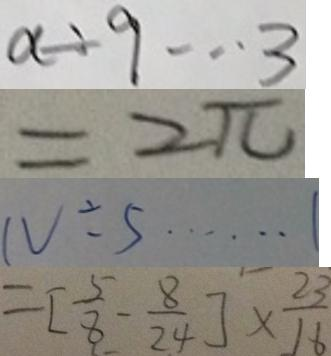Convert formula to latex. <formula><loc_0><loc_0><loc_500><loc_500>a \div 9 \cdots 3 
 = 2 \pi 
 N \div 5 \cdots 1 
 = [ \frac { 5 } { 8 } - \frac { 8 } { 2 4 } ] \times \frac { 2 3 } { 1 6 }</formula> 